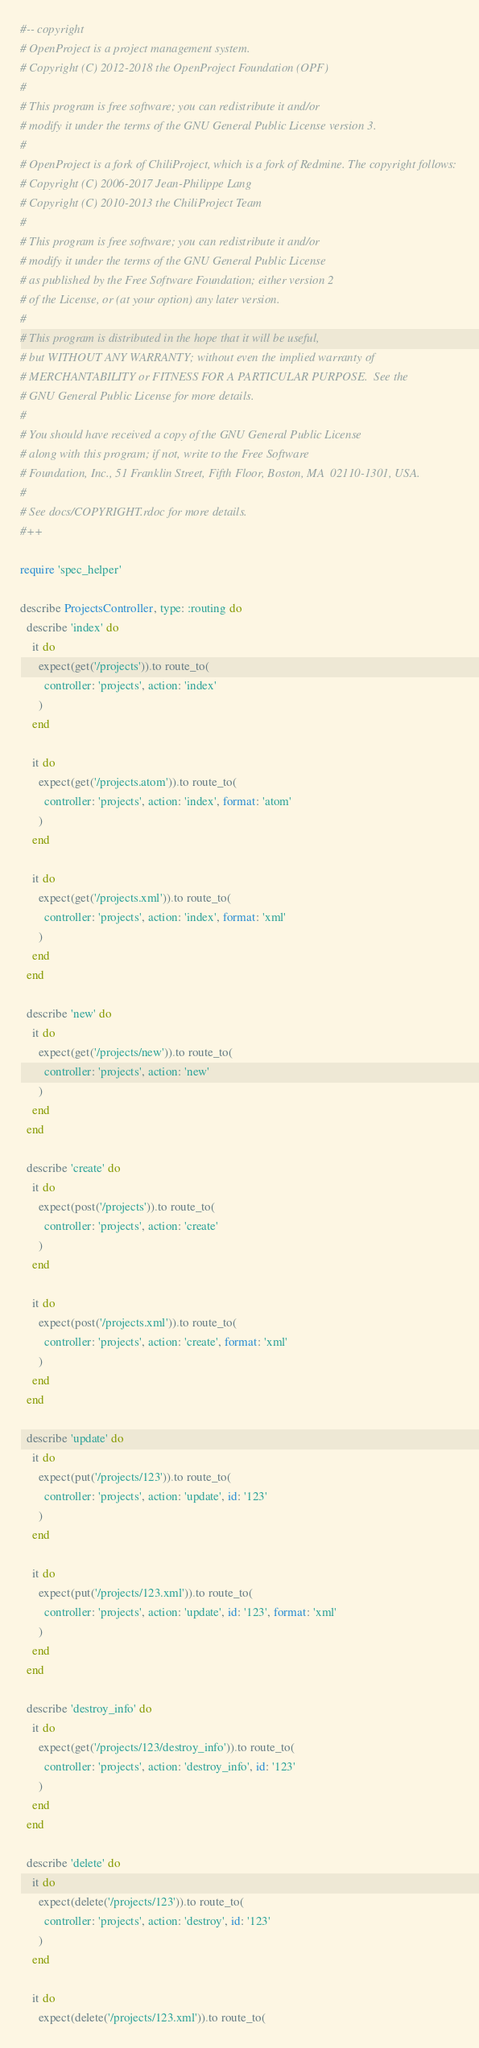Convert code to text. <code><loc_0><loc_0><loc_500><loc_500><_Ruby_>#-- copyright
# OpenProject is a project management system.
# Copyright (C) 2012-2018 the OpenProject Foundation (OPF)
#
# This program is free software; you can redistribute it and/or
# modify it under the terms of the GNU General Public License version 3.
#
# OpenProject is a fork of ChiliProject, which is a fork of Redmine. The copyright follows:
# Copyright (C) 2006-2017 Jean-Philippe Lang
# Copyright (C) 2010-2013 the ChiliProject Team
#
# This program is free software; you can redistribute it and/or
# modify it under the terms of the GNU General Public License
# as published by the Free Software Foundation; either version 2
# of the License, or (at your option) any later version.
#
# This program is distributed in the hope that it will be useful,
# but WITHOUT ANY WARRANTY; without even the implied warranty of
# MERCHANTABILITY or FITNESS FOR A PARTICULAR PURPOSE.  See the
# GNU General Public License for more details.
#
# You should have received a copy of the GNU General Public License
# along with this program; if not, write to the Free Software
# Foundation, Inc., 51 Franklin Street, Fifth Floor, Boston, MA  02110-1301, USA.
#
# See docs/COPYRIGHT.rdoc for more details.
#++

require 'spec_helper'

describe ProjectsController, type: :routing do
  describe 'index' do
    it do
      expect(get('/projects')).to route_to(
        controller: 'projects', action: 'index'
      )
    end

    it do
      expect(get('/projects.atom')).to route_to(
        controller: 'projects', action: 'index', format: 'atom'
      )
    end

    it do
      expect(get('/projects.xml')).to route_to(
        controller: 'projects', action: 'index', format: 'xml'
      )
    end
  end

  describe 'new' do
    it do
      expect(get('/projects/new')).to route_to(
        controller: 'projects', action: 'new'
      )
    end
  end

  describe 'create' do
    it do
      expect(post('/projects')).to route_to(
        controller: 'projects', action: 'create'
      )
    end

    it do
      expect(post('/projects.xml')).to route_to(
        controller: 'projects', action: 'create', format: 'xml'
      )
    end
  end

  describe 'update' do
    it do
      expect(put('/projects/123')).to route_to(
        controller: 'projects', action: 'update', id: '123'
      )
    end

    it do
      expect(put('/projects/123.xml')).to route_to(
        controller: 'projects', action: 'update', id: '123', format: 'xml'
      )
    end
  end

  describe 'destroy_info' do
    it do
      expect(get('/projects/123/destroy_info')).to route_to(
        controller: 'projects', action: 'destroy_info', id: '123'
      )
    end
  end

  describe 'delete' do
    it do
      expect(delete('/projects/123')).to route_to(
        controller: 'projects', action: 'destroy', id: '123'
      )
    end

    it do
      expect(delete('/projects/123.xml')).to route_to(</code> 